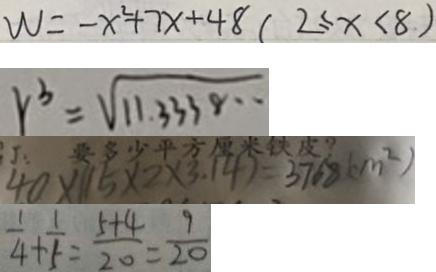Convert formula to latex. <formula><loc_0><loc_0><loc_500><loc_500>W = - x ^ { 2 } + 7 x + 4 8 ( 2 \leq x < 8 ) 
 r ^ { 3 } = \sqrt { 1 1 . 3 3 3 8 \cdots } 
 4 0 \times ( 1 5 \times 2 \times 3 . 1 4 ) = 3 7 6 8 ( c m ^ { 2 } ) 
 \frac { 1 } { 4 } + \frac { 1 } { 5 } = \frac { 5 + 4 } { 2 0 } = \frac { 9 } { 2 0 }</formula> 